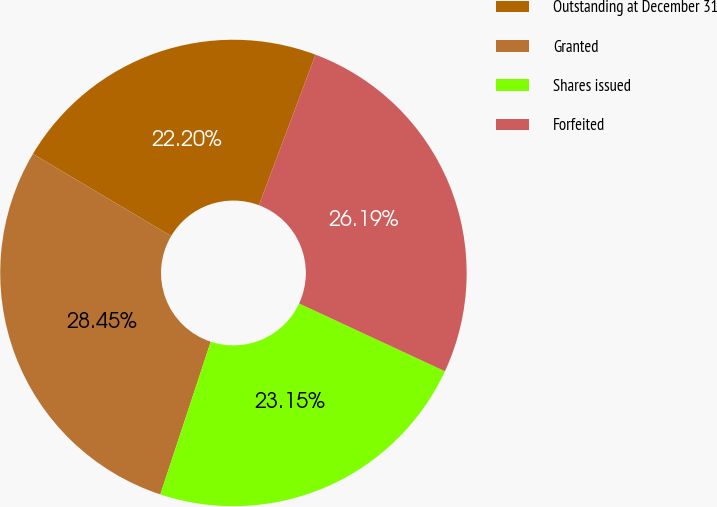Convert chart to OTSL. <chart><loc_0><loc_0><loc_500><loc_500><pie_chart><fcel>Outstanding at December 31<fcel>Granted<fcel>Shares issued<fcel>Forfeited<nl><fcel>22.2%<fcel>28.45%<fcel>23.15%<fcel>26.19%<nl></chart> 